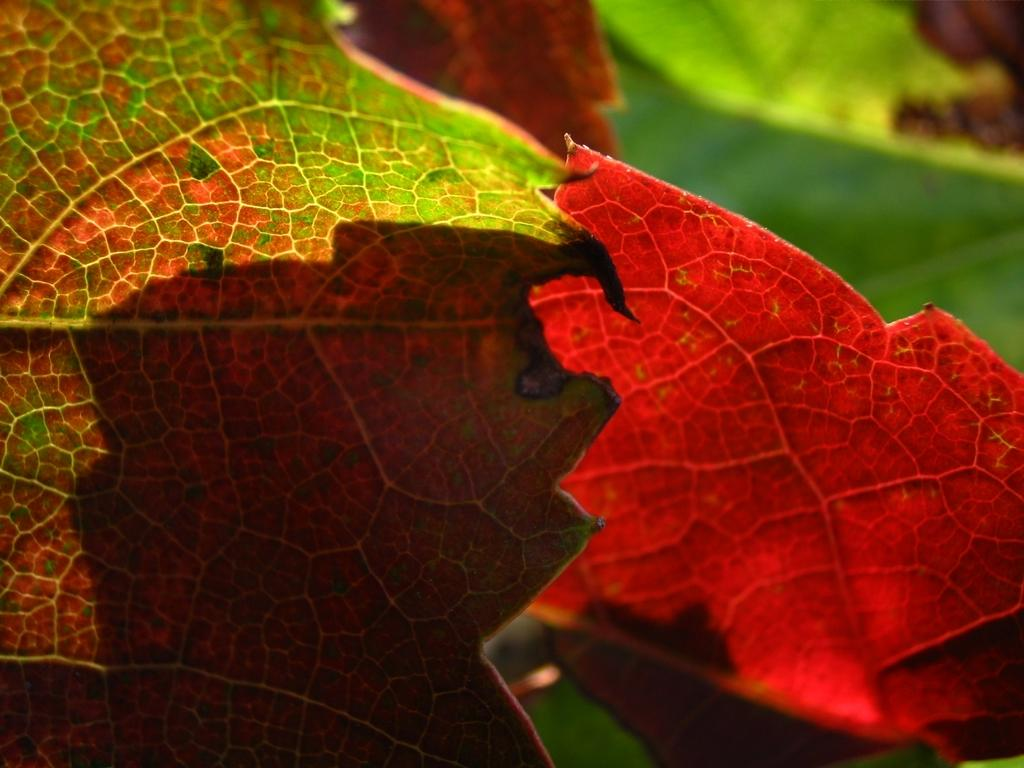What is visible in the foreground of the image? There are leaves in the foreground of the image. How would you describe the background of the image? The background of the image is blurred. How many dolls are sitting on the stone in the image? There are no dolls or stones present in the image. What color is the kitty in the image? There is no kitty present in the image. 